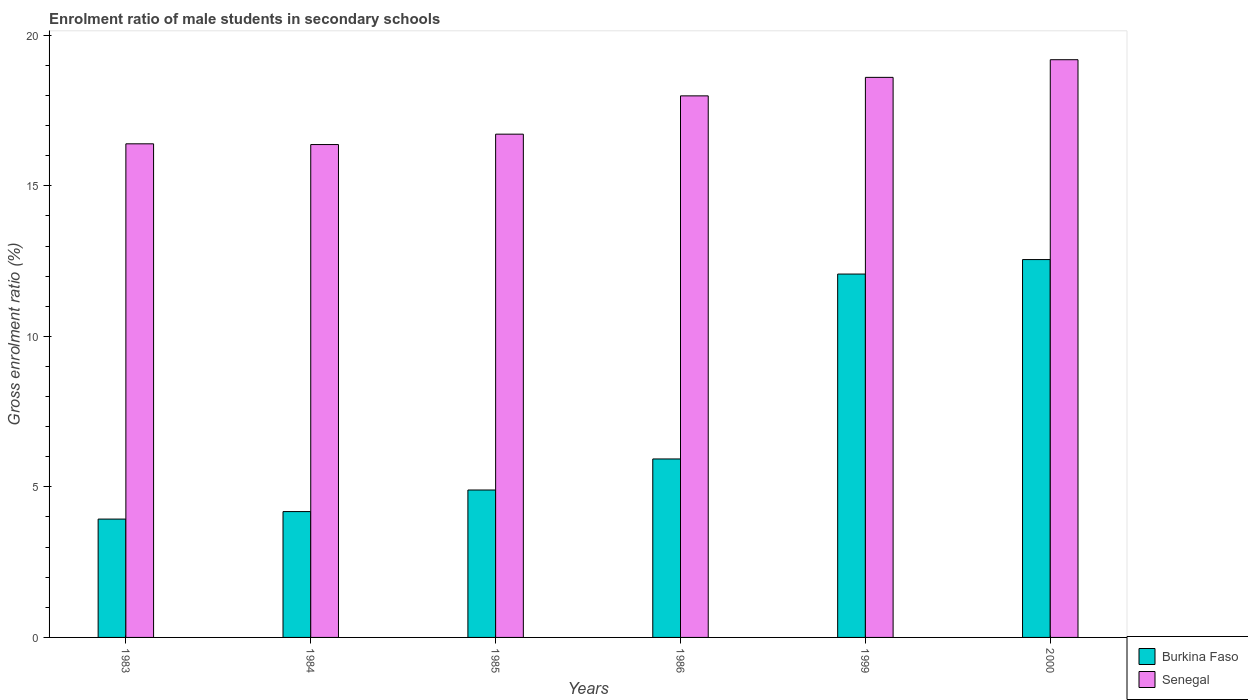Are the number of bars per tick equal to the number of legend labels?
Your response must be concise. Yes. How many bars are there on the 3rd tick from the left?
Your answer should be compact. 2. How many bars are there on the 1st tick from the right?
Provide a succinct answer. 2. In how many cases, is the number of bars for a given year not equal to the number of legend labels?
Offer a terse response. 0. What is the enrolment ratio of male students in secondary schools in Senegal in 1986?
Ensure brevity in your answer.  17.99. Across all years, what is the maximum enrolment ratio of male students in secondary schools in Senegal?
Offer a very short reply. 19.19. Across all years, what is the minimum enrolment ratio of male students in secondary schools in Burkina Faso?
Your response must be concise. 3.93. In which year was the enrolment ratio of male students in secondary schools in Burkina Faso maximum?
Offer a terse response. 2000. What is the total enrolment ratio of male students in secondary schools in Burkina Faso in the graph?
Ensure brevity in your answer.  43.55. What is the difference between the enrolment ratio of male students in secondary schools in Burkina Faso in 1983 and that in 1984?
Provide a short and direct response. -0.25. What is the difference between the enrolment ratio of male students in secondary schools in Burkina Faso in 2000 and the enrolment ratio of male students in secondary schools in Senegal in 1986?
Make the answer very short. -5.44. What is the average enrolment ratio of male students in secondary schools in Burkina Faso per year?
Offer a terse response. 7.26. In the year 1984, what is the difference between the enrolment ratio of male students in secondary schools in Burkina Faso and enrolment ratio of male students in secondary schools in Senegal?
Provide a short and direct response. -12.19. What is the ratio of the enrolment ratio of male students in secondary schools in Senegal in 1983 to that in 2000?
Provide a succinct answer. 0.85. Is the enrolment ratio of male students in secondary schools in Senegal in 1983 less than that in 1984?
Provide a succinct answer. No. Is the difference between the enrolment ratio of male students in secondary schools in Burkina Faso in 1986 and 2000 greater than the difference between the enrolment ratio of male students in secondary schools in Senegal in 1986 and 2000?
Offer a terse response. No. What is the difference between the highest and the second highest enrolment ratio of male students in secondary schools in Senegal?
Provide a succinct answer. 0.59. What is the difference between the highest and the lowest enrolment ratio of male students in secondary schools in Burkina Faso?
Ensure brevity in your answer.  8.62. In how many years, is the enrolment ratio of male students in secondary schools in Senegal greater than the average enrolment ratio of male students in secondary schools in Senegal taken over all years?
Keep it short and to the point. 3. What does the 1st bar from the left in 1985 represents?
Your answer should be very brief. Burkina Faso. What does the 1st bar from the right in 1985 represents?
Offer a terse response. Senegal. How many bars are there?
Keep it short and to the point. 12. How many years are there in the graph?
Your response must be concise. 6. What is the title of the graph?
Offer a terse response. Enrolment ratio of male students in secondary schools. Does "Mali" appear as one of the legend labels in the graph?
Offer a terse response. No. What is the label or title of the Y-axis?
Offer a very short reply. Gross enrolment ratio (%). What is the Gross enrolment ratio (%) in Burkina Faso in 1983?
Make the answer very short. 3.93. What is the Gross enrolment ratio (%) of Senegal in 1983?
Your response must be concise. 16.39. What is the Gross enrolment ratio (%) of Burkina Faso in 1984?
Ensure brevity in your answer.  4.18. What is the Gross enrolment ratio (%) in Senegal in 1984?
Your answer should be compact. 16.37. What is the Gross enrolment ratio (%) of Burkina Faso in 1985?
Provide a short and direct response. 4.9. What is the Gross enrolment ratio (%) in Senegal in 1985?
Your response must be concise. 16.71. What is the Gross enrolment ratio (%) of Burkina Faso in 1986?
Ensure brevity in your answer.  5.93. What is the Gross enrolment ratio (%) in Senegal in 1986?
Give a very brief answer. 17.99. What is the Gross enrolment ratio (%) of Burkina Faso in 1999?
Offer a terse response. 12.07. What is the Gross enrolment ratio (%) of Senegal in 1999?
Your response must be concise. 18.6. What is the Gross enrolment ratio (%) of Burkina Faso in 2000?
Ensure brevity in your answer.  12.55. What is the Gross enrolment ratio (%) in Senegal in 2000?
Provide a short and direct response. 19.19. Across all years, what is the maximum Gross enrolment ratio (%) of Burkina Faso?
Make the answer very short. 12.55. Across all years, what is the maximum Gross enrolment ratio (%) of Senegal?
Your answer should be very brief. 19.19. Across all years, what is the minimum Gross enrolment ratio (%) in Burkina Faso?
Offer a terse response. 3.93. Across all years, what is the minimum Gross enrolment ratio (%) in Senegal?
Ensure brevity in your answer.  16.37. What is the total Gross enrolment ratio (%) in Burkina Faso in the graph?
Your answer should be compact. 43.55. What is the total Gross enrolment ratio (%) in Senegal in the graph?
Give a very brief answer. 105.25. What is the difference between the Gross enrolment ratio (%) in Burkina Faso in 1983 and that in 1984?
Make the answer very short. -0.25. What is the difference between the Gross enrolment ratio (%) of Senegal in 1983 and that in 1984?
Give a very brief answer. 0.02. What is the difference between the Gross enrolment ratio (%) in Burkina Faso in 1983 and that in 1985?
Keep it short and to the point. -0.97. What is the difference between the Gross enrolment ratio (%) in Senegal in 1983 and that in 1985?
Your answer should be very brief. -0.32. What is the difference between the Gross enrolment ratio (%) of Burkina Faso in 1983 and that in 1986?
Keep it short and to the point. -2. What is the difference between the Gross enrolment ratio (%) in Senegal in 1983 and that in 1986?
Provide a succinct answer. -1.59. What is the difference between the Gross enrolment ratio (%) in Burkina Faso in 1983 and that in 1999?
Give a very brief answer. -8.14. What is the difference between the Gross enrolment ratio (%) in Senegal in 1983 and that in 1999?
Your answer should be compact. -2.21. What is the difference between the Gross enrolment ratio (%) of Burkina Faso in 1983 and that in 2000?
Keep it short and to the point. -8.62. What is the difference between the Gross enrolment ratio (%) in Senegal in 1983 and that in 2000?
Your response must be concise. -2.79. What is the difference between the Gross enrolment ratio (%) in Burkina Faso in 1984 and that in 1985?
Make the answer very short. -0.72. What is the difference between the Gross enrolment ratio (%) of Senegal in 1984 and that in 1985?
Your response must be concise. -0.35. What is the difference between the Gross enrolment ratio (%) in Burkina Faso in 1984 and that in 1986?
Your answer should be very brief. -1.75. What is the difference between the Gross enrolment ratio (%) of Senegal in 1984 and that in 1986?
Your response must be concise. -1.62. What is the difference between the Gross enrolment ratio (%) of Burkina Faso in 1984 and that in 1999?
Make the answer very short. -7.89. What is the difference between the Gross enrolment ratio (%) of Senegal in 1984 and that in 1999?
Provide a short and direct response. -2.23. What is the difference between the Gross enrolment ratio (%) in Burkina Faso in 1984 and that in 2000?
Your response must be concise. -8.37. What is the difference between the Gross enrolment ratio (%) in Senegal in 1984 and that in 2000?
Your response must be concise. -2.82. What is the difference between the Gross enrolment ratio (%) in Burkina Faso in 1985 and that in 1986?
Offer a terse response. -1.03. What is the difference between the Gross enrolment ratio (%) of Senegal in 1985 and that in 1986?
Provide a succinct answer. -1.27. What is the difference between the Gross enrolment ratio (%) of Burkina Faso in 1985 and that in 1999?
Offer a very short reply. -7.17. What is the difference between the Gross enrolment ratio (%) of Senegal in 1985 and that in 1999?
Give a very brief answer. -1.89. What is the difference between the Gross enrolment ratio (%) of Burkina Faso in 1985 and that in 2000?
Your response must be concise. -7.65. What is the difference between the Gross enrolment ratio (%) of Senegal in 1985 and that in 2000?
Offer a terse response. -2.47. What is the difference between the Gross enrolment ratio (%) in Burkina Faso in 1986 and that in 1999?
Offer a terse response. -6.14. What is the difference between the Gross enrolment ratio (%) in Senegal in 1986 and that in 1999?
Give a very brief answer. -0.61. What is the difference between the Gross enrolment ratio (%) in Burkina Faso in 1986 and that in 2000?
Give a very brief answer. -6.62. What is the difference between the Gross enrolment ratio (%) of Senegal in 1986 and that in 2000?
Offer a terse response. -1.2. What is the difference between the Gross enrolment ratio (%) in Burkina Faso in 1999 and that in 2000?
Provide a short and direct response. -0.48. What is the difference between the Gross enrolment ratio (%) in Senegal in 1999 and that in 2000?
Provide a short and direct response. -0.59. What is the difference between the Gross enrolment ratio (%) in Burkina Faso in 1983 and the Gross enrolment ratio (%) in Senegal in 1984?
Offer a terse response. -12.44. What is the difference between the Gross enrolment ratio (%) of Burkina Faso in 1983 and the Gross enrolment ratio (%) of Senegal in 1985?
Offer a terse response. -12.78. What is the difference between the Gross enrolment ratio (%) in Burkina Faso in 1983 and the Gross enrolment ratio (%) in Senegal in 1986?
Provide a short and direct response. -14.06. What is the difference between the Gross enrolment ratio (%) in Burkina Faso in 1983 and the Gross enrolment ratio (%) in Senegal in 1999?
Keep it short and to the point. -14.67. What is the difference between the Gross enrolment ratio (%) in Burkina Faso in 1983 and the Gross enrolment ratio (%) in Senegal in 2000?
Your response must be concise. -15.26. What is the difference between the Gross enrolment ratio (%) in Burkina Faso in 1984 and the Gross enrolment ratio (%) in Senegal in 1985?
Keep it short and to the point. -12.53. What is the difference between the Gross enrolment ratio (%) in Burkina Faso in 1984 and the Gross enrolment ratio (%) in Senegal in 1986?
Your response must be concise. -13.81. What is the difference between the Gross enrolment ratio (%) of Burkina Faso in 1984 and the Gross enrolment ratio (%) of Senegal in 1999?
Your answer should be very brief. -14.42. What is the difference between the Gross enrolment ratio (%) of Burkina Faso in 1984 and the Gross enrolment ratio (%) of Senegal in 2000?
Give a very brief answer. -15.01. What is the difference between the Gross enrolment ratio (%) in Burkina Faso in 1985 and the Gross enrolment ratio (%) in Senegal in 1986?
Your answer should be compact. -13.09. What is the difference between the Gross enrolment ratio (%) in Burkina Faso in 1985 and the Gross enrolment ratio (%) in Senegal in 1999?
Provide a short and direct response. -13.71. What is the difference between the Gross enrolment ratio (%) of Burkina Faso in 1985 and the Gross enrolment ratio (%) of Senegal in 2000?
Make the answer very short. -14.29. What is the difference between the Gross enrolment ratio (%) of Burkina Faso in 1986 and the Gross enrolment ratio (%) of Senegal in 1999?
Offer a terse response. -12.67. What is the difference between the Gross enrolment ratio (%) of Burkina Faso in 1986 and the Gross enrolment ratio (%) of Senegal in 2000?
Your answer should be very brief. -13.26. What is the difference between the Gross enrolment ratio (%) in Burkina Faso in 1999 and the Gross enrolment ratio (%) in Senegal in 2000?
Provide a short and direct response. -7.12. What is the average Gross enrolment ratio (%) of Burkina Faso per year?
Keep it short and to the point. 7.26. What is the average Gross enrolment ratio (%) in Senegal per year?
Offer a terse response. 17.54. In the year 1983, what is the difference between the Gross enrolment ratio (%) of Burkina Faso and Gross enrolment ratio (%) of Senegal?
Provide a succinct answer. -12.46. In the year 1984, what is the difference between the Gross enrolment ratio (%) in Burkina Faso and Gross enrolment ratio (%) in Senegal?
Provide a succinct answer. -12.19. In the year 1985, what is the difference between the Gross enrolment ratio (%) in Burkina Faso and Gross enrolment ratio (%) in Senegal?
Give a very brief answer. -11.82. In the year 1986, what is the difference between the Gross enrolment ratio (%) in Burkina Faso and Gross enrolment ratio (%) in Senegal?
Give a very brief answer. -12.06. In the year 1999, what is the difference between the Gross enrolment ratio (%) of Burkina Faso and Gross enrolment ratio (%) of Senegal?
Give a very brief answer. -6.53. In the year 2000, what is the difference between the Gross enrolment ratio (%) in Burkina Faso and Gross enrolment ratio (%) in Senegal?
Keep it short and to the point. -6.64. What is the ratio of the Gross enrolment ratio (%) in Burkina Faso in 1983 to that in 1984?
Provide a succinct answer. 0.94. What is the ratio of the Gross enrolment ratio (%) of Senegal in 1983 to that in 1984?
Give a very brief answer. 1. What is the ratio of the Gross enrolment ratio (%) of Burkina Faso in 1983 to that in 1985?
Offer a terse response. 0.8. What is the ratio of the Gross enrolment ratio (%) in Senegal in 1983 to that in 1985?
Offer a very short reply. 0.98. What is the ratio of the Gross enrolment ratio (%) of Burkina Faso in 1983 to that in 1986?
Keep it short and to the point. 0.66. What is the ratio of the Gross enrolment ratio (%) in Senegal in 1983 to that in 1986?
Your response must be concise. 0.91. What is the ratio of the Gross enrolment ratio (%) of Burkina Faso in 1983 to that in 1999?
Make the answer very short. 0.33. What is the ratio of the Gross enrolment ratio (%) of Senegal in 1983 to that in 1999?
Your answer should be compact. 0.88. What is the ratio of the Gross enrolment ratio (%) in Burkina Faso in 1983 to that in 2000?
Give a very brief answer. 0.31. What is the ratio of the Gross enrolment ratio (%) in Senegal in 1983 to that in 2000?
Your answer should be very brief. 0.85. What is the ratio of the Gross enrolment ratio (%) in Burkina Faso in 1984 to that in 1985?
Provide a succinct answer. 0.85. What is the ratio of the Gross enrolment ratio (%) in Senegal in 1984 to that in 1985?
Make the answer very short. 0.98. What is the ratio of the Gross enrolment ratio (%) in Burkina Faso in 1984 to that in 1986?
Give a very brief answer. 0.71. What is the ratio of the Gross enrolment ratio (%) in Senegal in 1984 to that in 1986?
Provide a short and direct response. 0.91. What is the ratio of the Gross enrolment ratio (%) of Burkina Faso in 1984 to that in 1999?
Offer a very short reply. 0.35. What is the ratio of the Gross enrolment ratio (%) in Senegal in 1984 to that in 1999?
Your answer should be compact. 0.88. What is the ratio of the Gross enrolment ratio (%) of Burkina Faso in 1984 to that in 2000?
Ensure brevity in your answer.  0.33. What is the ratio of the Gross enrolment ratio (%) of Senegal in 1984 to that in 2000?
Keep it short and to the point. 0.85. What is the ratio of the Gross enrolment ratio (%) of Burkina Faso in 1985 to that in 1986?
Keep it short and to the point. 0.83. What is the ratio of the Gross enrolment ratio (%) of Senegal in 1985 to that in 1986?
Keep it short and to the point. 0.93. What is the ratio of the Gross enrolment ratio (%) of Burkina Faso in 1985 to that in 1999?
Your answer should be very brief. 0.41. What is the ratio of the Gross enrolment ratio (%) of Senegal in 1985 to that in 1999?
Offer a very short reply. 0.9. What is the ratio of the Gross enrolment ratio (%) in Burkina Faso in 1985 to that in 2000?
Your answer should be compact. 0.39. What is the ratio of the Gross enrolment ratio (%) of Senegal in 1985 to that in 2000?
Your answer should be very brief. 0.87. What is the ratio of the Gross enrolment ratio (%) in Burkina Faso in 1986 to that in 1999?
Keep it short and to the point. 0.49. What is the ratio of the Gross enrolment ratio (%) of Senegal in 1986 to that in 1999?
Your answer should be compact. 0.97. What is the ratio of the Gross enrolment ratio (%) in Burkina Faso in 1986 to that in 2000?
Ensure brevity in your answer.  0.47. What is the ratio of the Gross enrolment ratio (%) of Senegal in 1986 to that in 2000?
Provide a succinct answer. 0.94. What is the ratio of the Gross enrolment ratio (%) in Burkina Faso in 1999 to that in 2000?
Provide a succinct answer. 0.96. What is the ratio of the Gross enrolment ratio (%) in Senegal in 1999 to that in 2000?
Offer a terse response. 0.97. What is the difference between the highest and the second highest Gross enrolment ratio (%) in Burkina Faso?
Ensure brevity in your answer.  0.48. What is the difference between the highest and the second highest Gross enrolment ratio (%) in Senegal?
Your answer should be very brief. 0.59. What is the difference between the highest and the lowest Gross enrolment ratio (%) in Burkina Faso?
Keep it short and to the point. 8.62. What is the difference between the highest and the lowest Gross enrolment ratio (%) in Senegal?
Your answer should be very brief. 2.82. 